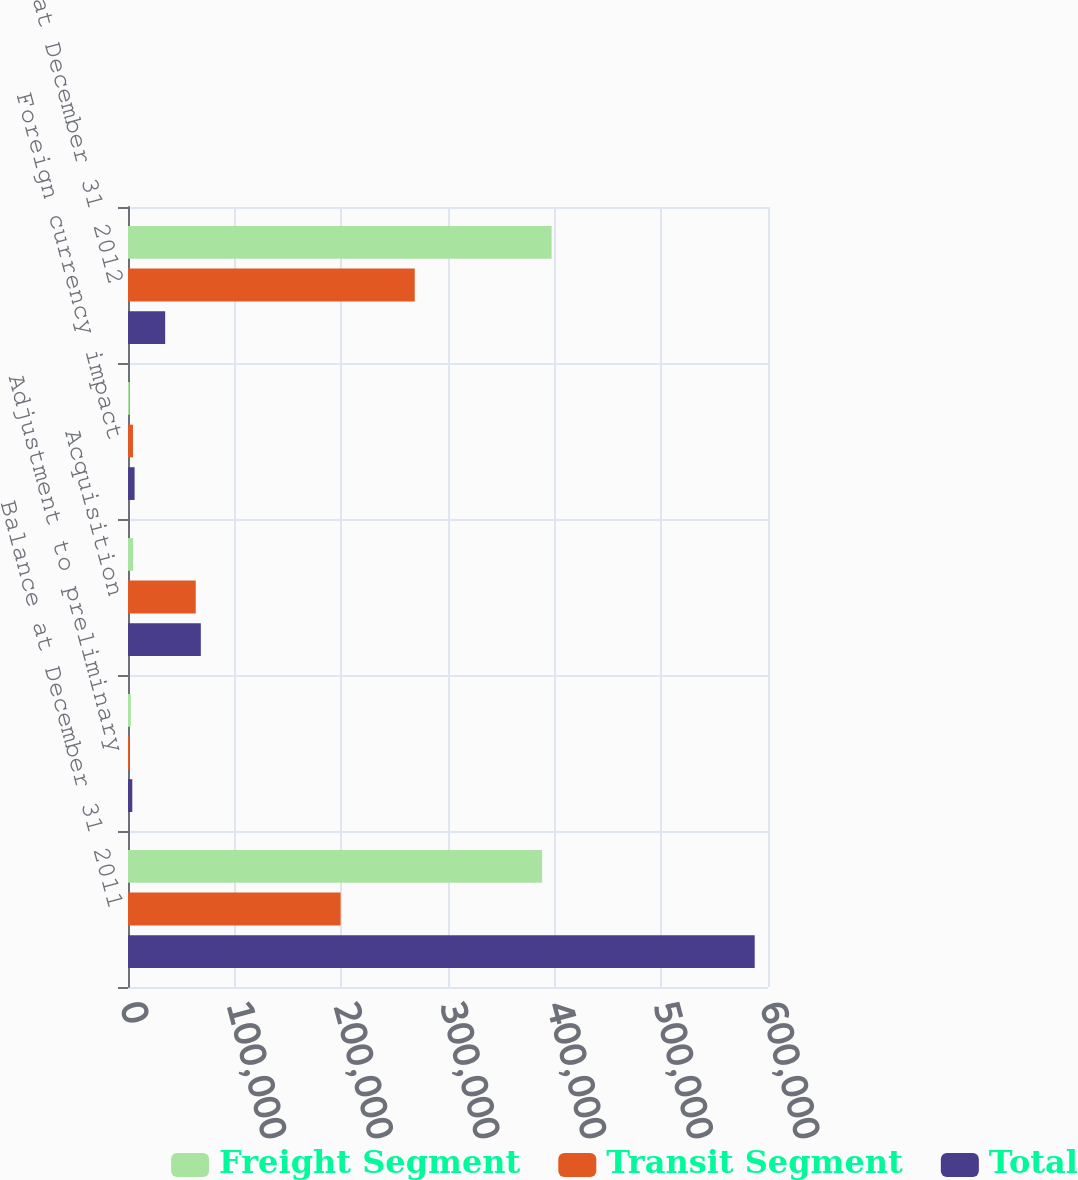<chart> <loc_0><loc_0><loc_500><loc_500><stacked_bar_chart><ecel><fcel>Balance at December 31 2011<fcel>Adjustment to preliminary<fcel>Acquisition<fcel>Foreign currency impact<fcel>Balance at December 31 2012<nl><fcel>Freight Segment<fcel>388221<fcel>2660<fcel>4781<fcel>1522<fcel>397184<nl><fcel>Transit Segment<fcel>199310<fcel>1364<fcel>63505<fcel>4659<fcel>268838<nl><fcel>Total<fcel>587531<fcel>4024<fcel>68286<fcel>6181<fcel>34843<nl></chart> 